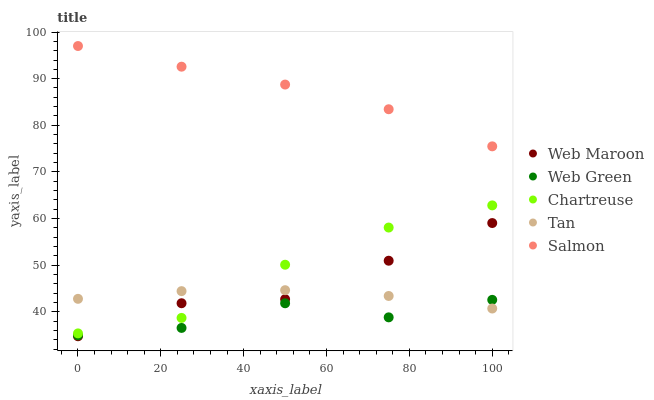Does Web Green have the minimum area under the curve?
Answer yes or no. Yes. Does Salmon have the maximum area under the curve?
Answer yes or no. Yes. Does Chartreuse have the minimum area under the curve?
Answer yes or no. No. Does Chartreuse have the maximum area under the curve?
Answer yes or no. No. Is Tan the smoothest?
Answer yes or no. Yes. Is Web Green the roughest?
Answer yes or no. Yes. Is Chartreuse the smoothest?
Answer yes or no. No. Is Chartreuse the roughest?
Answer yes or no. No. Does Web Maroon have the lowest value?
Answer yes or no. Yes. Does Chartreuse have the lowest value?
Answer yes or no. No. Does Salmon have the highest value?
Answer yes or no. Yes. Does Chartreuse have the highest value?
Answer yes or no. No. Is Tan less than Salmon?
Answer yes or no. Yes. Is Chartreuse greater than Web Green?
Answer yes or no. Yes. Does Web Green intersect Web Maroon?
Answer yes or no. Yes. Is Web Green less than Web Maroon?
Answer yes or no. No. Is Web Green greater than Web Maroon?
Answer yes or no. No. Does Tan intersect Salmon?
Answer yes or no. No. 